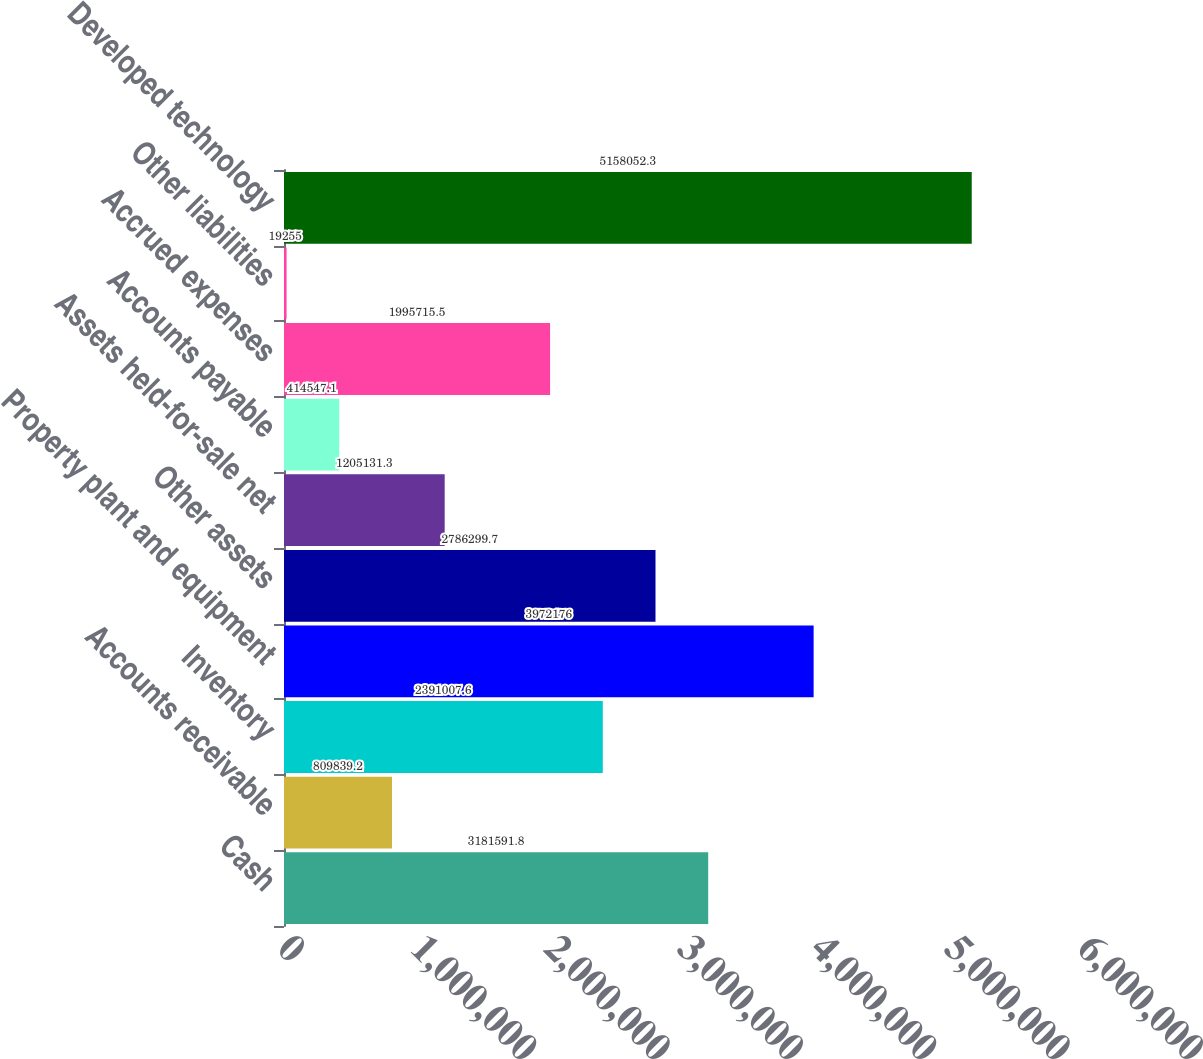Convert chart. <chart><loc_0><loc_0><loc_500><loc_500><bar_chart><fcel>Cash<fcel>Accounts receivable<fcel>Inventory<fcel>Property plant and equipment<fcel>Other assets<fcel>Assets held-for-sale net<fcel>Accounts payable<fcel>Accrued expenses<fcel>Other liabilities<fcel>Developed technology<nl><fcel>3.18159e+06<fcel>809839<fcel>2.39101e+06<fcel>3.97218e+06<fcel>2.7863e+06<fcel>1.20513e+06<fcel>414547<fcel>1.99572e+06<fcel>19255<fcel>5.15805e+06<nl></chart> 